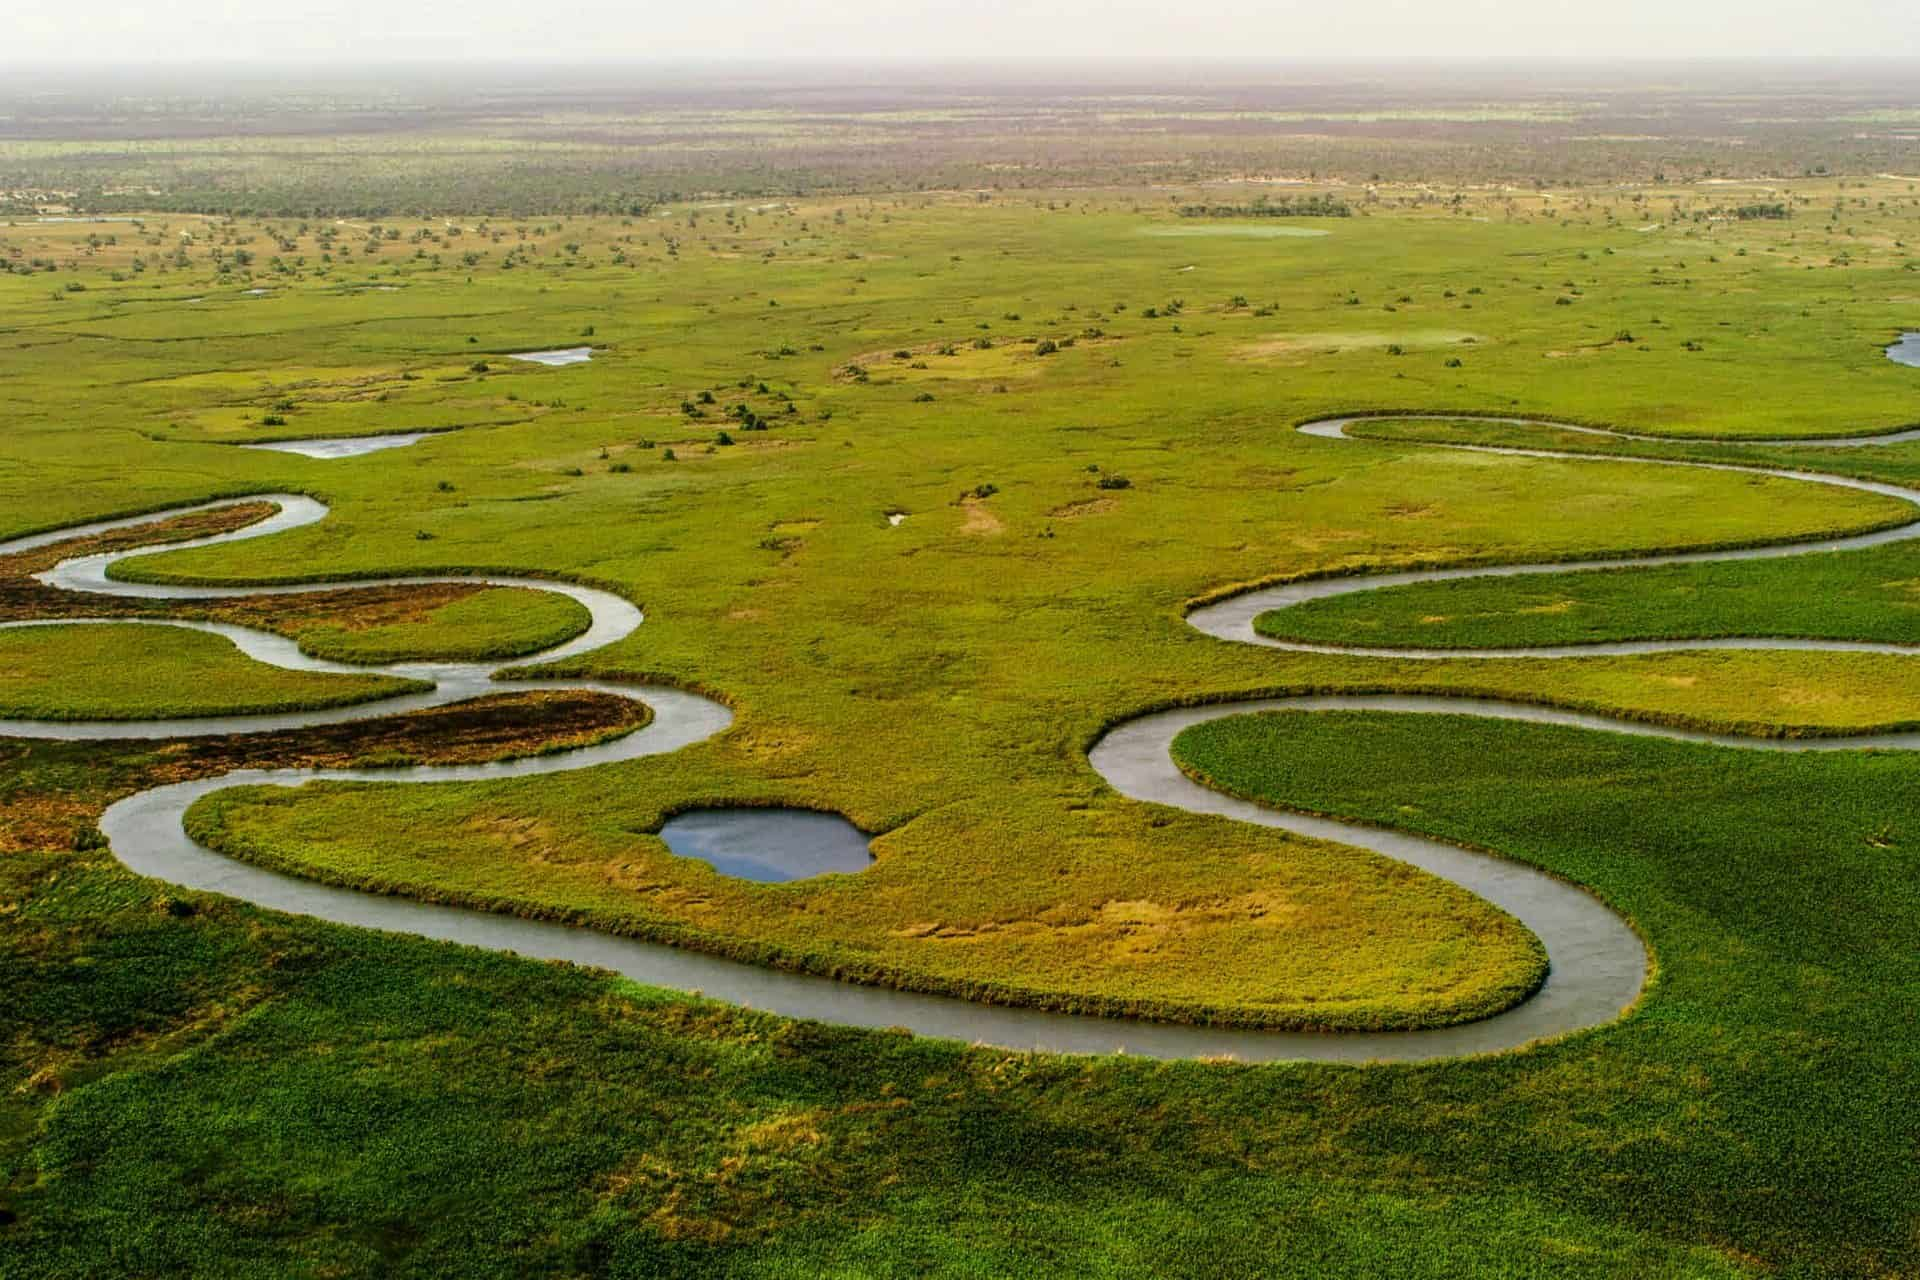Can you tell me about the conservation efforts in place for the Okavango Delta? Efforts to conserve the Okavango Delta are multifaceted. Recognizing its ecological importance and vulnerability, the delta was declared a UNESCO World Heritage Site in 2014, which provides an international framework for its protection. Local and international organizations are active in researching and monitoring its biodiversity, implementing anti-poaching initiatives, and promoting sustainable tourism practices. These efforts aim to mitigate the impact of factors such as climate change, overfishing, and encroachment by agricultural activities. Additionally, community-driven conservation programs aim to involve local populations in protecting the delta while fostering eco-friendly economic opportunities. 